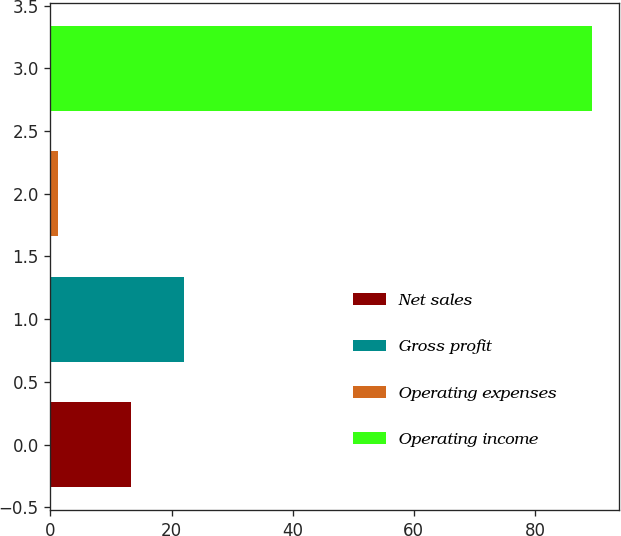<chart> <loc_0><loc_0><loc_500><loc_500><bar_chart><fcel>Net sales<fcel>Gross profit<fcel>Operating expenses<fcel>Operating income<nl><fcel>13.3<fcel>22.12<fcel>1.2<fcel>89.4<nl></chart> 